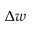<formula> <loc_0><loc_0><loc_500><loc_500>\Delta w</formula> 